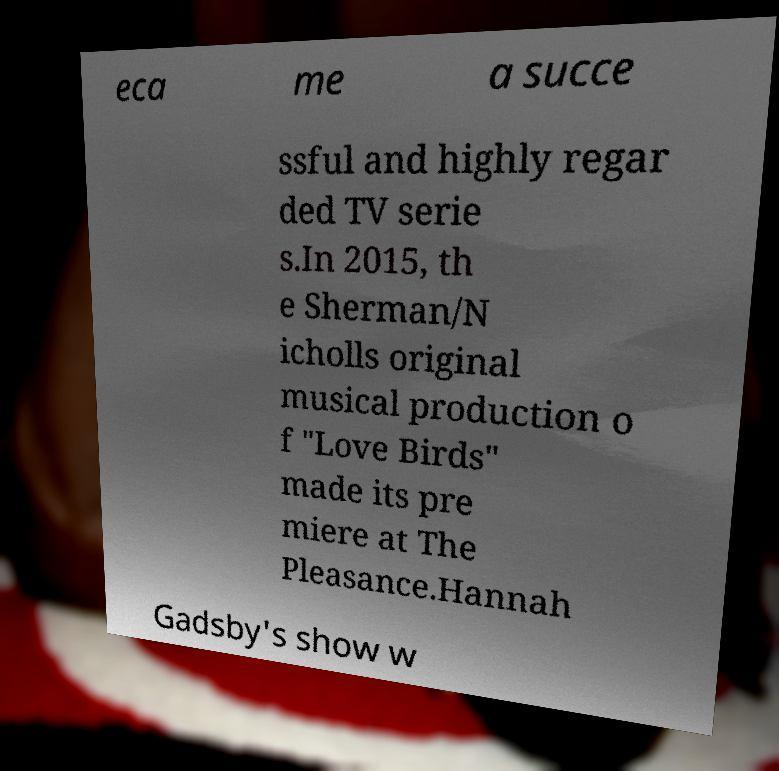Could you extract and type out the text from this image? eca me a succe ssful and highly regar ded TV serie s.In 2015, th e Sherman/N icholls original musical production o f "Love Birds" made its pre miere at The Pleasance.Hannah Gadsby's show w 